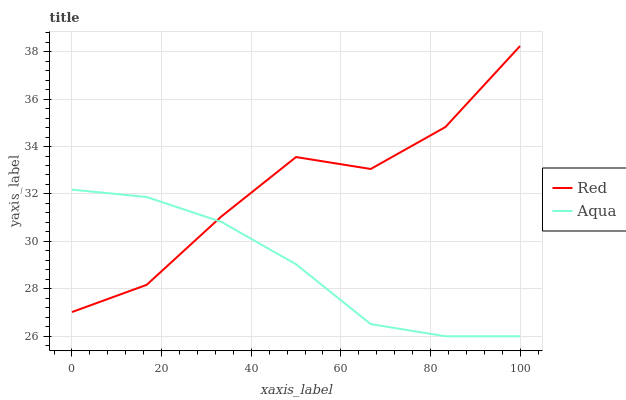Does Aqua have the minimum area under the curve?
Answer yes or no. Yes. Does Red have the maximum area under the curve?
Answer yes or no. Yes. Does Red have the minimum area under the curve?
Answer yes or no. No. Is Aqua the smoothest?
Answer yes or no. Yes. Is Red the roughest?
Answer yes or no. Yes. Is Red the smoothest?
Answer yes or no. No. Does Aqua have the lowest value?
Answer yes or no. Yes. Does Red have the lowest value?
Answer yes or no. No. Does Red have the highest value?
Answer yes or no. Yes. Does Red intersect Aqua?
Answer yes or no. Yes. Is Red less than Aqua?
Answer yes or no. No. Is Red greater than Aqua?
Answer yes or no. No. 